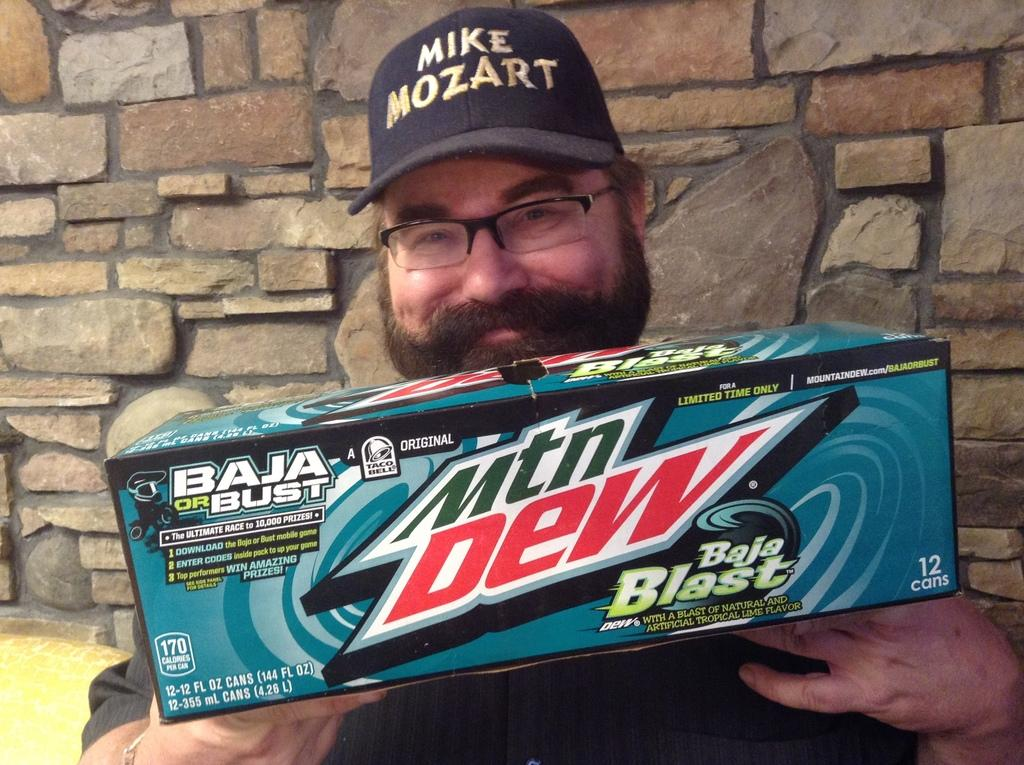What is the person in the image doing? The person is holding a box. What can be seen on the person's face? The person is wearing spectacles and is smiling. What type of headwear is the person wearing? The person is wearing a cap. What type of tooth is visible in the image? There is no tooth visible in the image; the person is wearing spectacles, not a dental appliance. 